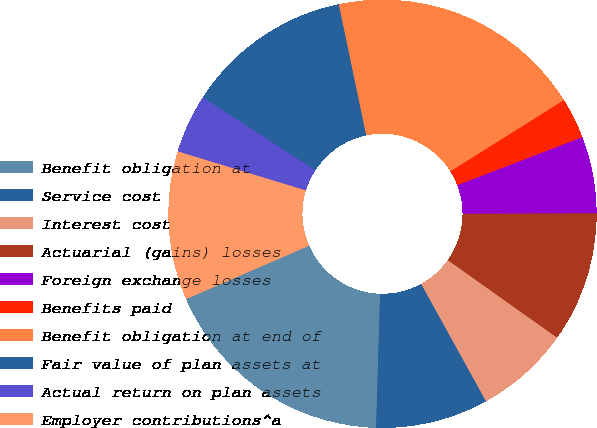Convert chart. <chart><loc_0><loc_0><loc_500><loc_500><pie_chart><fcel>Benefit obligation at<fcel>Service cost<fcel>Interest cost<fcel>Actuarial (gains) losses<fcel>Foreign exchange losses<fcel>Benefits paid<fcel>Benefit obligation at end of<fcel>Fair value of plan assets at<fcel>Actual return on plan assets<fcel>Employer contributions^a<nl><fcel>18.01%<fcel>8.51%<fcel>7.15%<fcel>9.86%<fcel>5.79%<fcel>3.08%<fcel>19.37%<fcel>12.58%<fcel>4.44%<fcel>11.22%<nl></chart> 